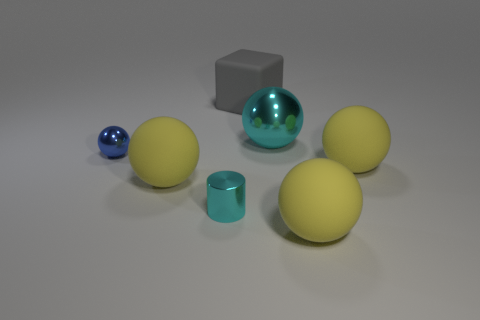What is the texture of the objects other than the cyan sphere? The smaller blue sphere has a glossy texture, the gray cube has a matte finish, and the three yellow spheres appear to have a slightly textured, matte surface. 